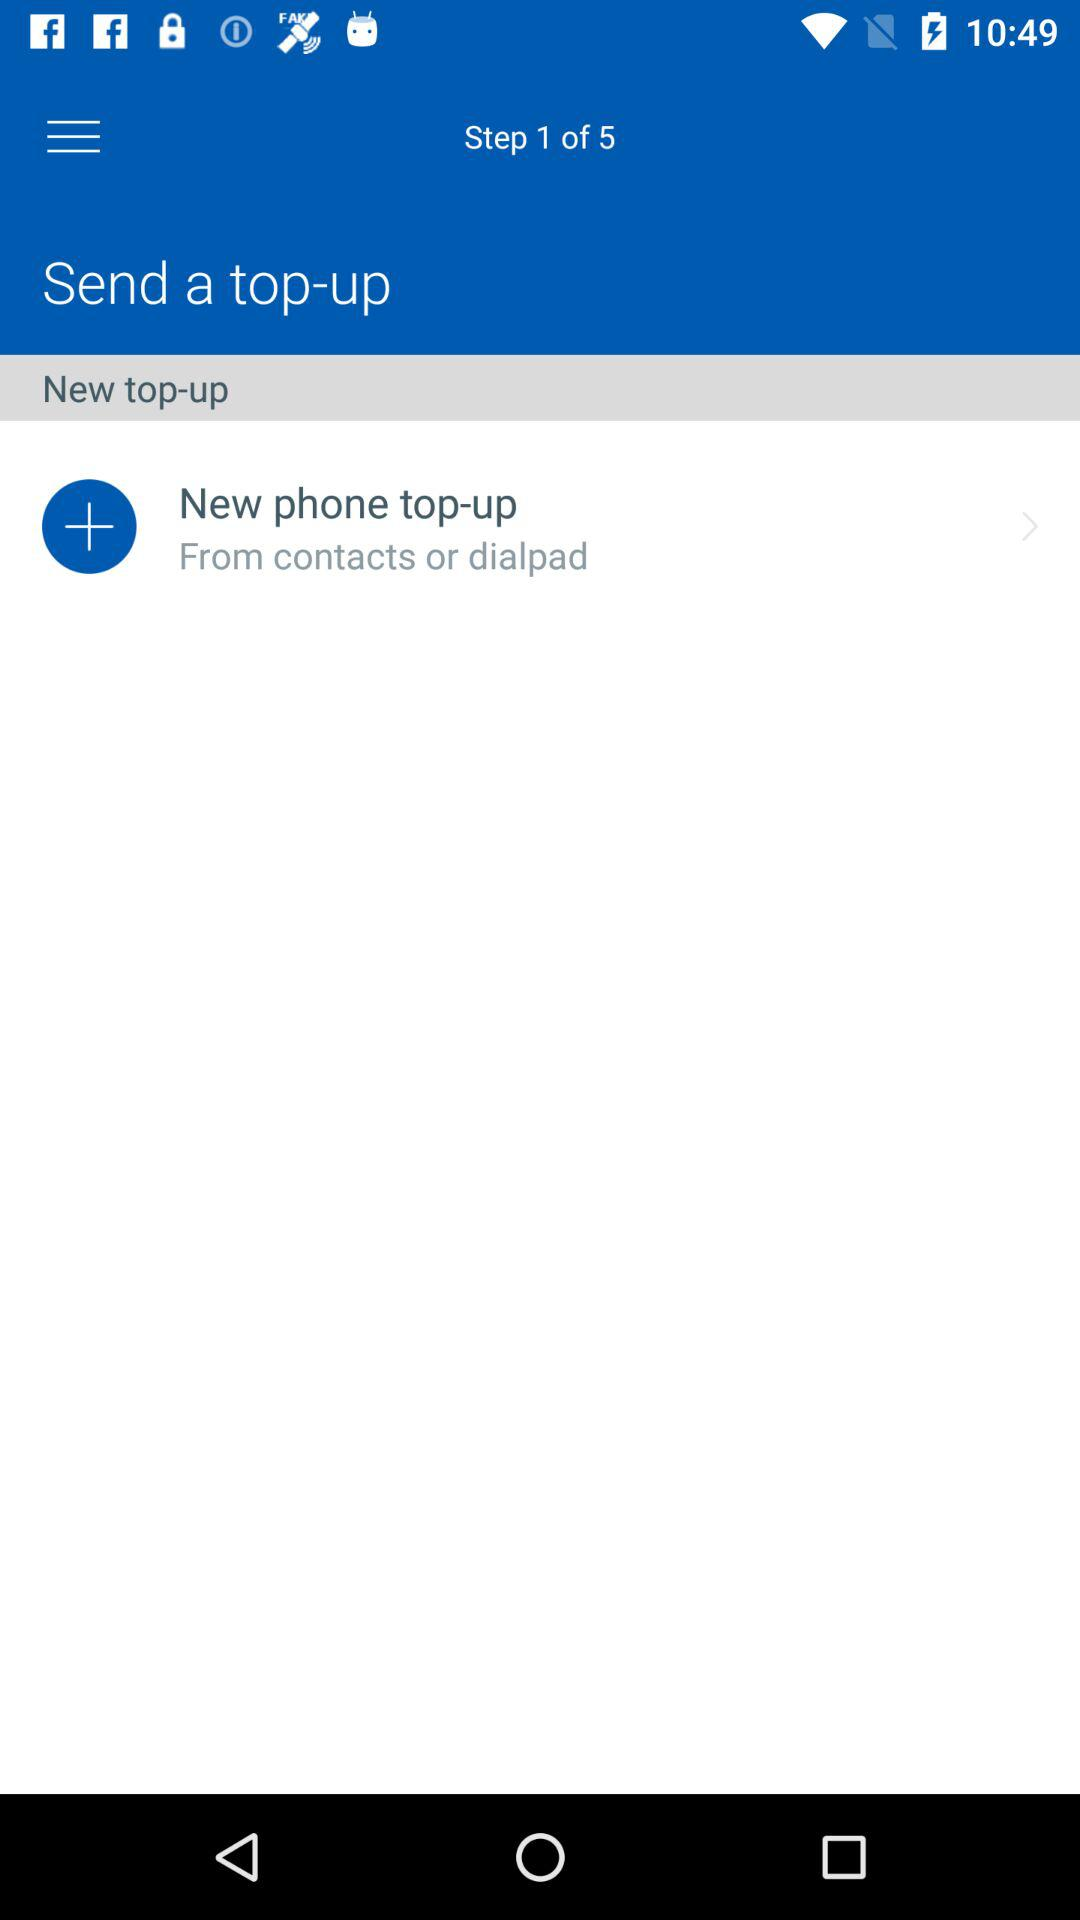How many steps are there in the process?
Answer the question using a single word or phrase. 5 